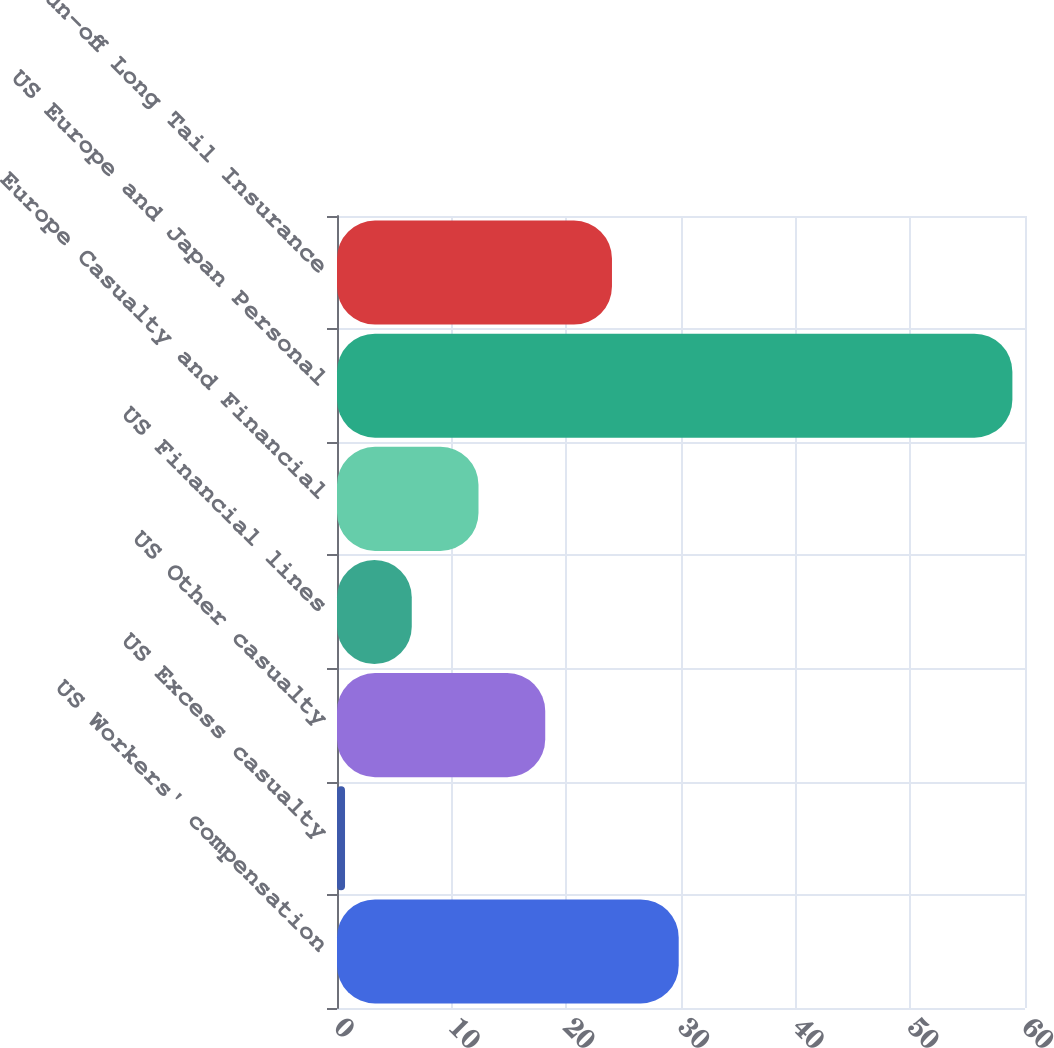<chart> <loc_0><loc_0><loc_500><loc_500><bar_chart><fcel>US Workers' compensation<fcel>US Excess casualty<fcel>US Other casualty<fcel>US Financial lines<fcel>Europe Casualty and Financial<fcel>US Europe and Japan Personal<fcel>US Run-off Long Tail Insurance<nl><fcel>29.8<fcel>0.7<fcel>18.16<fcel>6.52<fcel>12.34<fcel>58.9<fcel>23.98<nl></chart> 